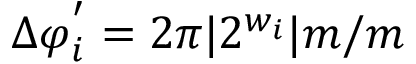Convert formula to latex. <formula><loc_0><loc_0><loc_500><loc_500>\Delta \varphi _ { i } ^ { ^ { \prime } } = 2 \pi | 2 ^ { w _ { i } } | { m } / m</formula> 